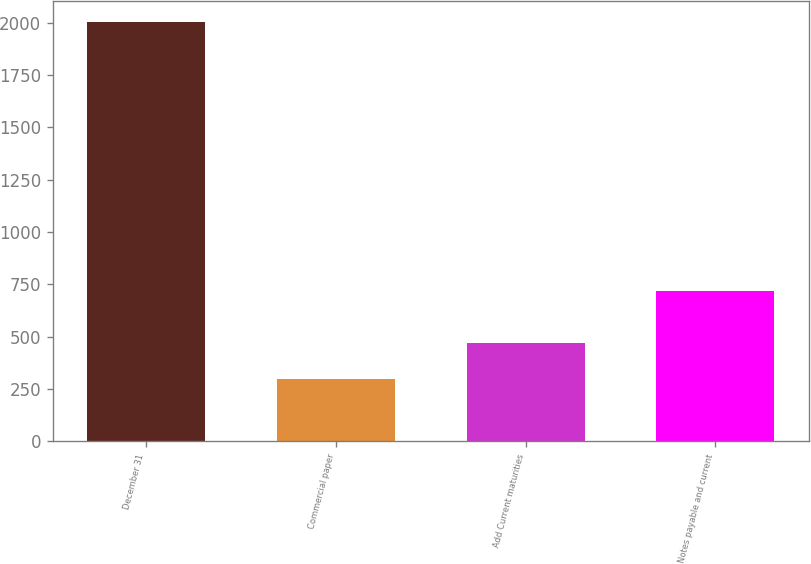<chart> <loc_0><loc_0><loc_500><loc_500><bar_chart><fcel>December 31<fcel>Commercial paper<fcel>Add Current maturities<fcel>Notes payable and current<nl><fcel>2004<fcel>300<fcel>470.4<fcel>717<nl></chart> 